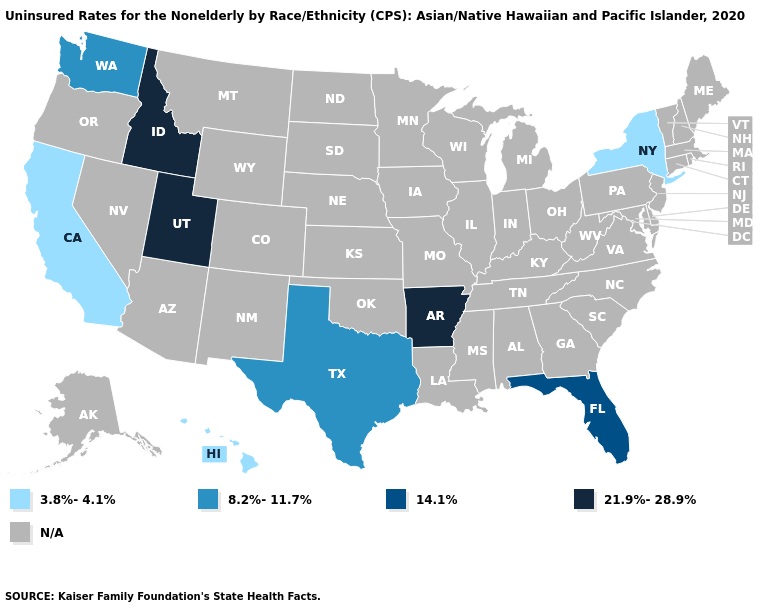What is the value of Massachusetts?
Concise answer only. N/A. Does New York have the highest value in the USA?
Concise answer only. No. Name the states that have a value in the range 8.2%-11.7%?
Keep it brief. Texas, Washington. What is the lowest value in the USA?
Answer briefly. 3.8%-4.1%. Name the states that have a value in the range N/A?
Concise answer only. Alabama, Alaska, Arizona, Colorado, Connecticut, Delaware, Georgia, Illinois, Indiana, Iowa, Kansas, Kentucky, Louisiana, Maine, Maryland, Massachusetts, Michigan, Minnesota, Mississippi, Missouri, Montana, Nebraska, Nevada, New Hampshire, New Jersey, New Mexico, North Carolina, North Dakota, Ohio, Oklahoma, Oregon, Pennsylvania, Rhode Island, South Carolina, South Dakota, Tennessee, Vermont, Virginia, West Virginia, Wisconsin, Wyoming. What is the highest value in states that border Wyoming?
Be succinct. 21.9%-28.9%. Name the states that have a value in the range 8.2%-11.7%?
Short answer required. Texas, Washington. Name the states that have a value in the range 14.1%?
Keep it brief. Florida. What is the value of Nebraska?
Be succinct. N/A. What is the value of South Dakota?
Write a very short answer. N/A. Name the states that have a value in the range 14.1%?
Give a very brief answer. Florida. Does Texas have the highest value in the South?
Short answer required. No. Name the states that have a value in the range 14.1%?
Concise answer only. Florida. Which states have the lowest value in the Northeast?
Short answer required. New York. 